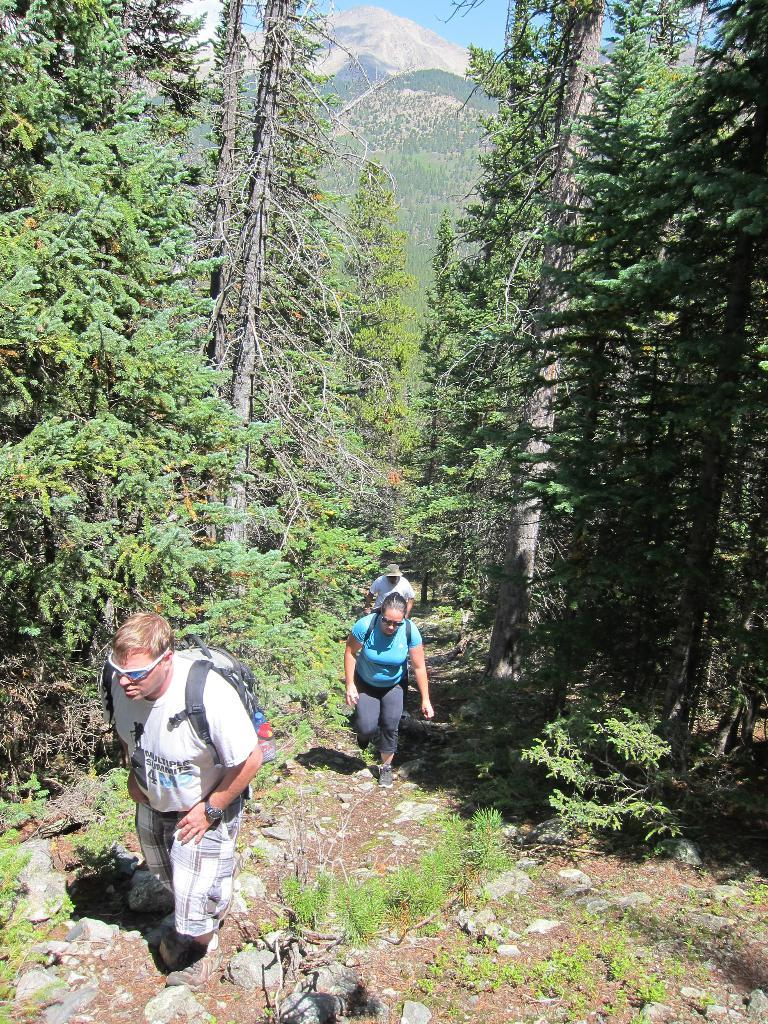What are the people in the image doing? The people in the image are walking. What can be seen in the background of the image? There are trees, mountains, and sky visible in the background of the image. What is at the bottom of the image? There are rocks at the bottom of the image. What type of cork can be seen floating in the river in the image? There is no river or cork present in the image. How many screws are visible on the trees in the image? There are no screws visible on the trees in the image. 